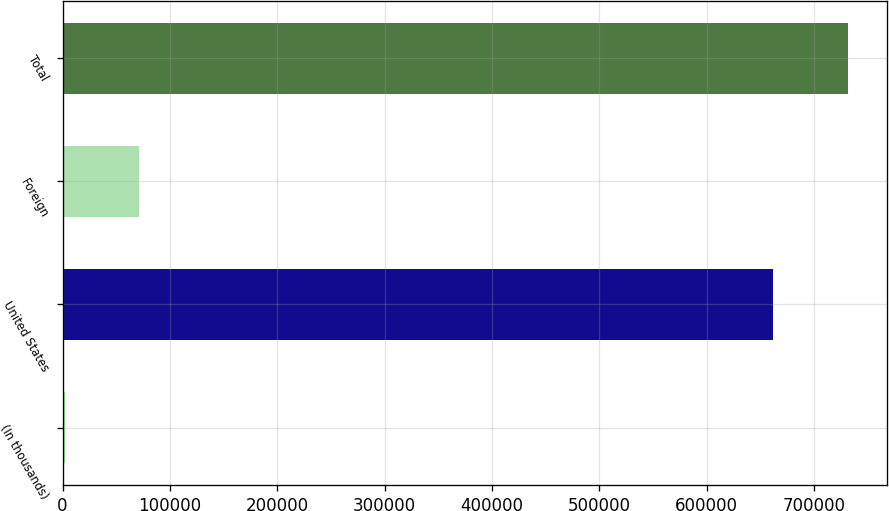<chart> <loc_0><loc_0><loc_500><loc_500><bar_chart><fcel>(In thousands)<fcel>United States<fcel>Foreign<fcel>Total<nl><fcel>2007<fcel>661966<fcel>71447.5<fcel>731406<nl></chart> 